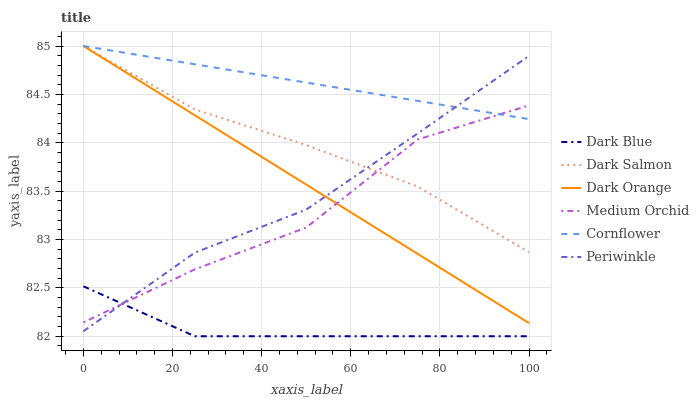Does Dark Orange have the minimum area under the curve?
Answer yes or no. No. Does Dark Orange have the maximum area under the curve?
Answer yes or no. No. Is Medium Orchid the smoothest?
Answer yes or no. No. Is Dark Orange the roughest?
Answer yes or no. No. Does Dark Orange have the lowest value?
Answer yes or no. No. Does Medium Orchid have the highest value?
Answer yes or no. No. Is Dark Blue less than Dark Orange?
Answer yes or no. Yes. Is Dark Orange greater than Dark Blue?
Answer yes or no. Yes. Does Dark Blue intersect Dark Orange?
Answer yes or no. No. 